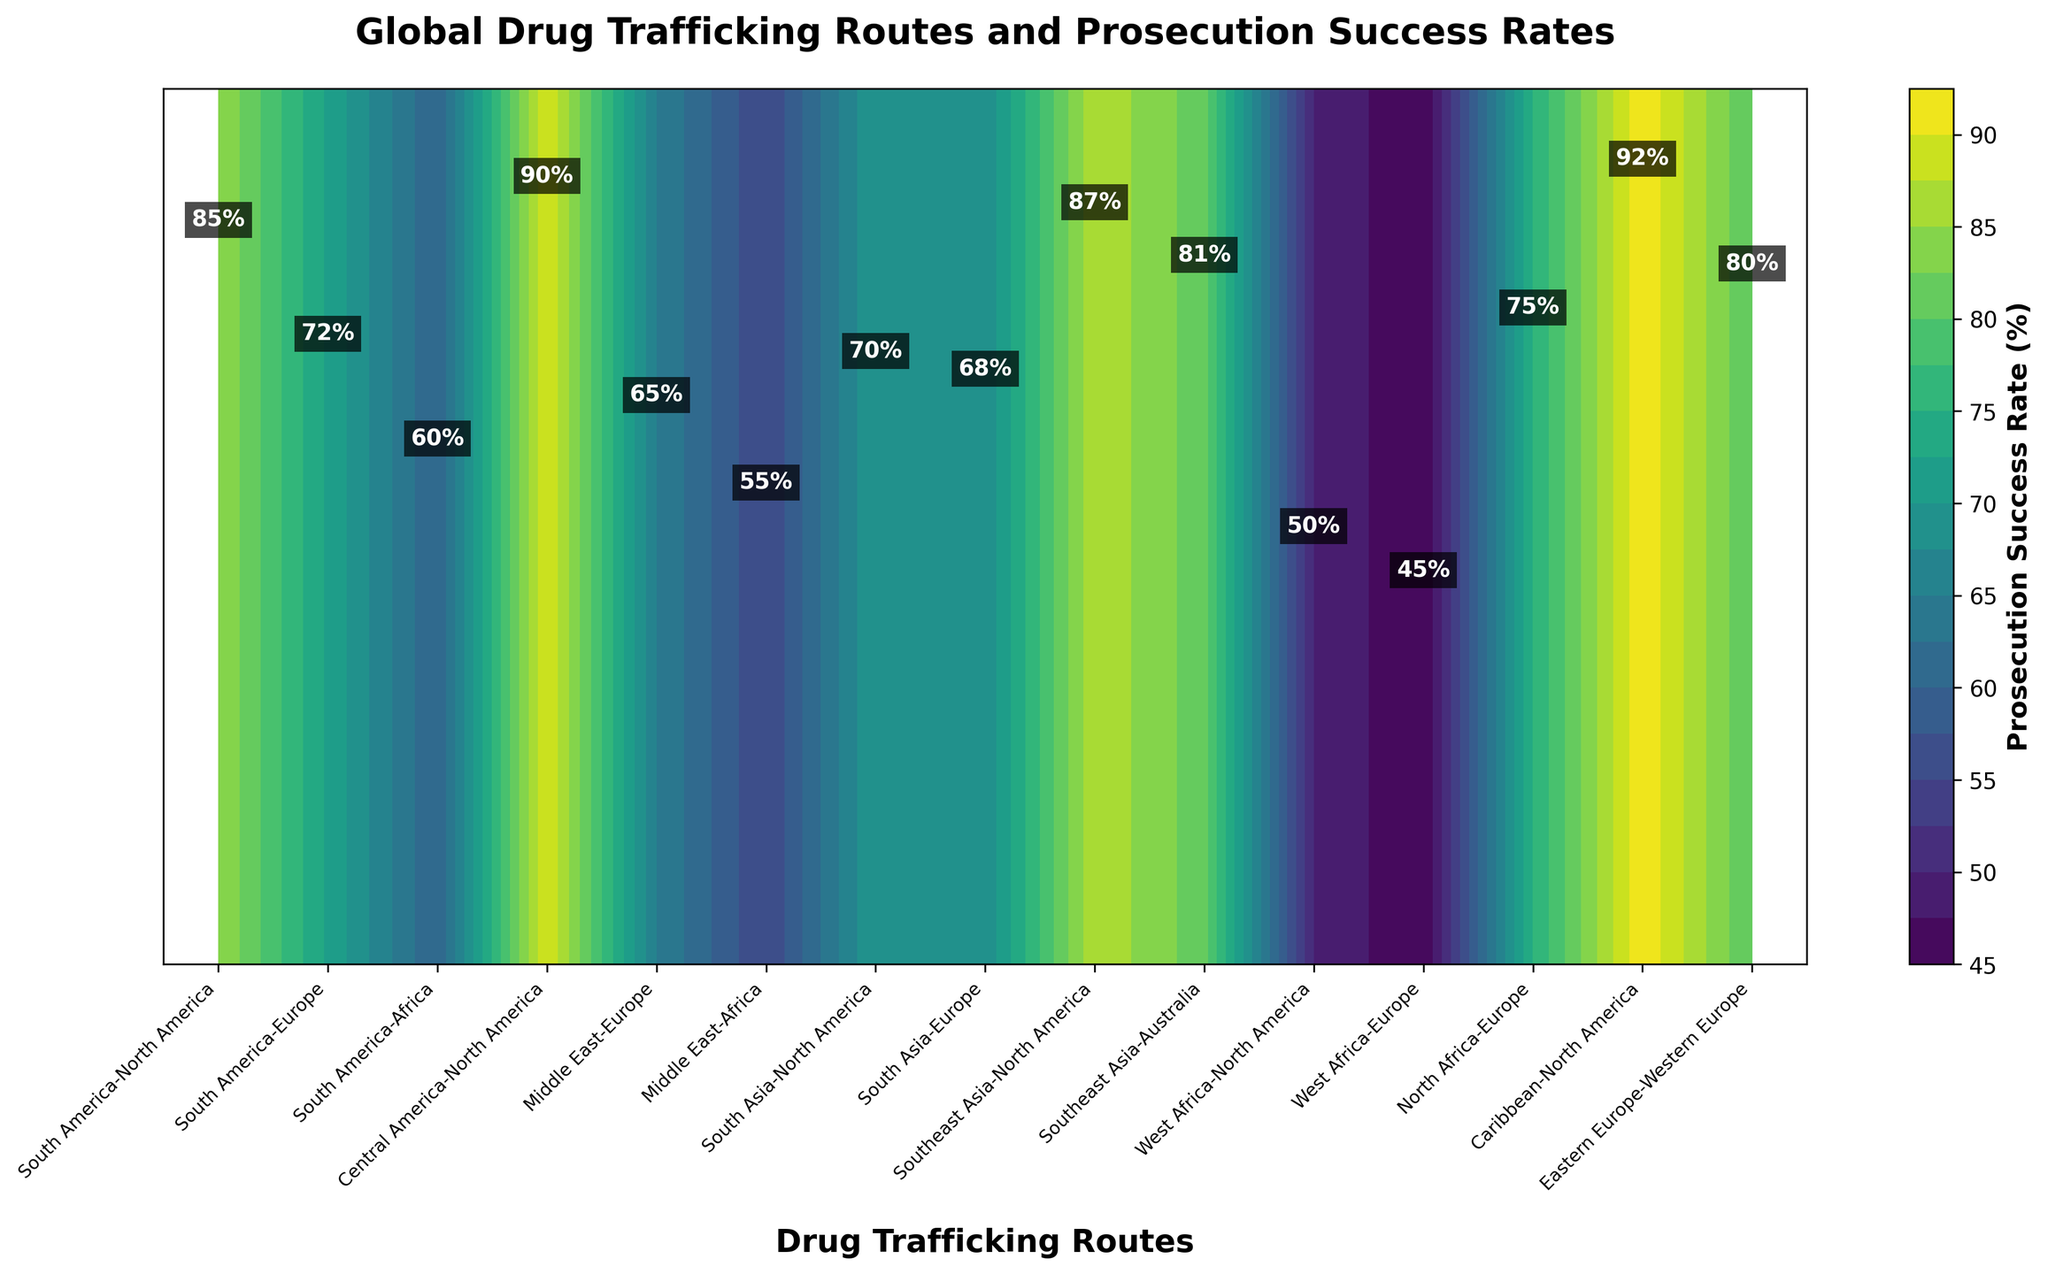what is the title of the figure? The title of the figure is located at the top of the plot area and provides a summary of the visualized data.
Answer: Global Drug Trafficking Routes and Prosecution Success Rates What is the prosecution success rate for the South America to North America route? To find the prosecution success rate for the South America to North America route, look for the specific label on the x-axis, follow the contour plot to locate the numerical success rate associated with it.
Answer: 85% Which route has the highest prosecution success rate? To determine the route with the highest prosecution success rate, scan through the labeled success rates or identify the darkest portion of the contour plot, which represents the highest success rate.
Answer: Caribbean-North America Compare the prosecution success rates between South America to Europe and Middle East to Africa routes. Which one is higher and by how much? The label for the South America to Europe route shows a success rate of 72%, and the Middle East to Africa route shows a success rate of 55%. Calculate the difference: 72% - 55%= 17%.
Answer: South America to Europe is higher by 17% What is the average prosecution success rate for all the routes shown in the plot? Sum all the prosecution success rates for each route and divide by the total number of routes. The sum is: 85 + 72 + 60 + 90 + 65 + 55 + 70 + 68 + 87 + 81 + 50 + 45 + 75 + 92 + 80 = 1025. Divide by the number of routes, which is 15: 1025/15 = 68.33.
Answer: 68.33% How do the prosecution success rates trend from the routes originating in South America compared to those from West Africa? Look at the prosecution success rates for routes originating in South America (85, 72, 60) and those from West Africa (50, 45). Observe that South American routes generally have higher success rates.
Answer: South America routes have higher rates What is the prosecution success rate for the Central America to North America route, and is it above or below the average success rate? Find the rate for Central America to North America (90%) and compare it with the previously calculated average (68.33%). Since 90% is greater than 68.33%, it is above the average.
Answer: 90%, above average Which region has a prosecution success rate close to the figure's average? Identify values close to the calculated average (68.33%). South Asia to Europe (68%) has a prosecution success rate close to the average.
Answer: South Asia to Europe Where does the prosecution success rate dip below 60%, and which routes are involved? Locate areas in the contour plot where success rates are less than 60%. The routes involved are Middle East to Africa (55%) and West Africa to North America (50%), and West Africa to Europe (45%).
Answer: Middle East to Africa, West Africa to North America, West Africa to Europe 